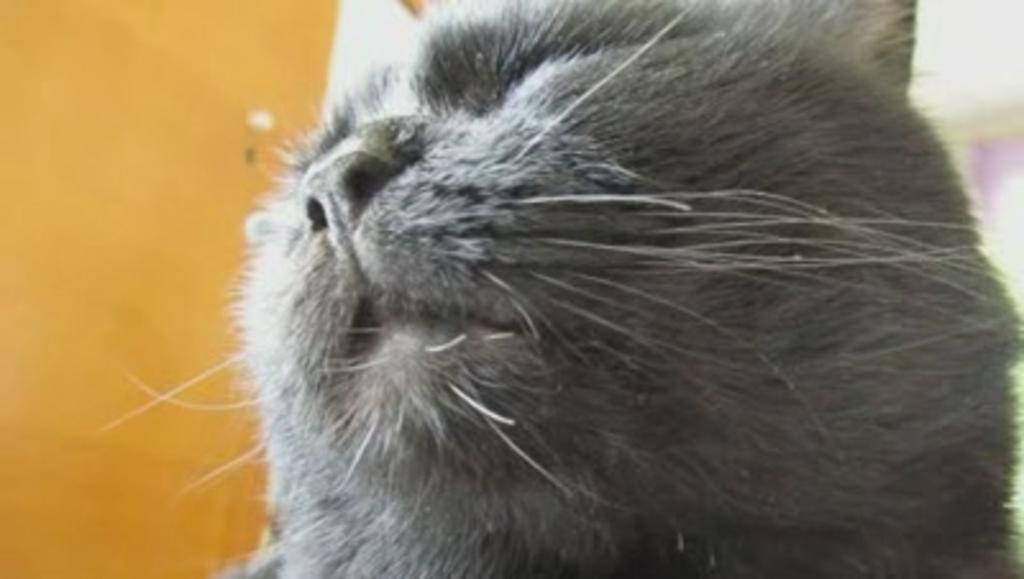What type of animal is in the image? There is a cat in the image. What color is the cat? The cat is black in color. What is located on the left side of the image? There is a door on the left side of the image. Where is the faucet located in the image? There is no faucet present in the image. What type of drum is visible in the image? There is no drum present in the image. 